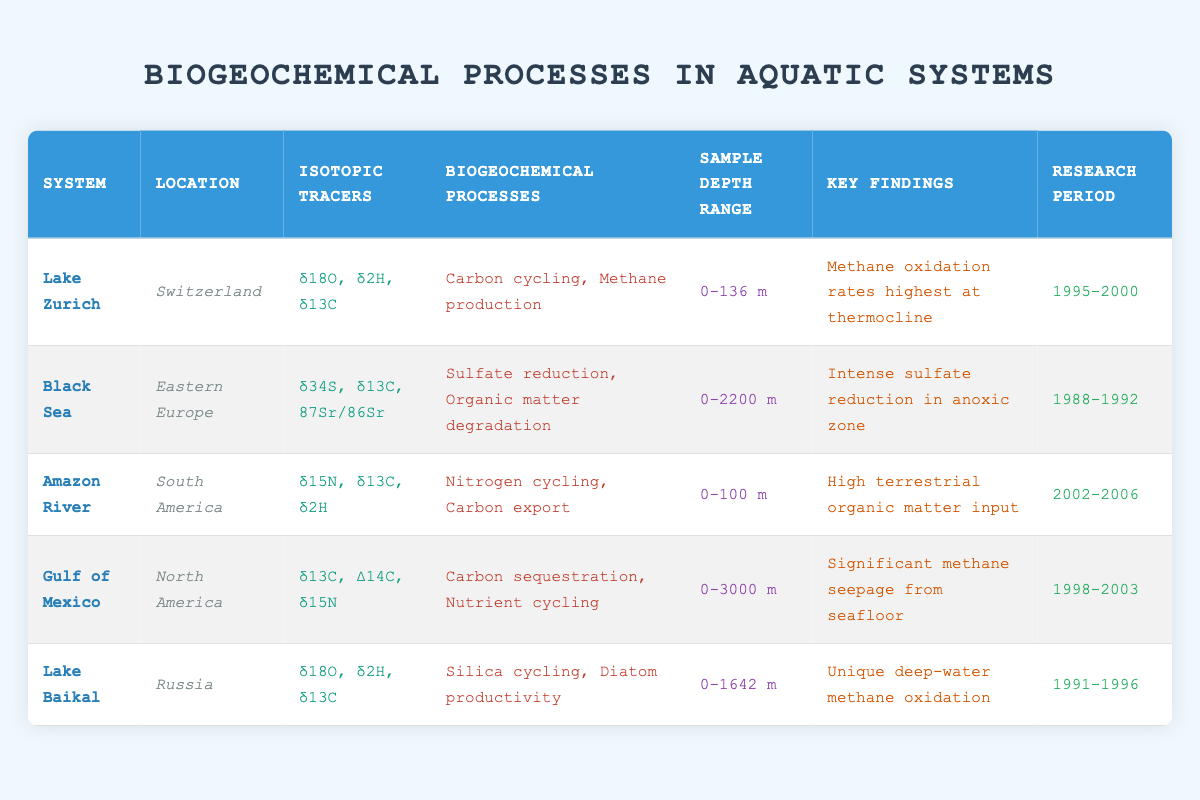What isotopic tracers are used in the Black Sea? The table lists the isotopic tracers utilized in the Black Sea as δ34S, δ13C, and 87Sr/86Sr, which can be found in the relevant row under the "Isotopic Tracers" column.
Answer: δ34S, δ13C, 87Sr/86Sr Which aquatic system has the deepest sample depth range? From the depth range column, the Gulf of Mexico has a sample depth range of 0-3000 m, which is the largest compared to the other systems listed.
Answer: Gulf of Mexico Is carbon cycling one of the primary biogeochemical processes studied in Lake Baikal? By inspecting the "Primary Biogeochemical Processes" column for Lake Baikal, it can be seen that the processes include silica cycling and diatom productivity, meaning carbon cycling is not studied there.
Answer: No What is the research period for the Amazon River study? The research period for the Amazon River study can be found in the "Research Period" column, which states the period as 2002-2006.
Answer: 2002-2006 Which system had key findings related to intense sulfate reduction? The key finding regarding intense sulfate reduction is associated with the Black Sea, as seen in the corresponding row's "Key Findings" column, indicating this specific biogeochemical activity.
Answer: Black Sea How many different isotopic tracers are used across all systems in the table? By enumerating the distinct isotopic tracers from each system, δ18O, δ2H, δ13C, δ34S, 87Sr/86Sr, δ15N, and Δ14C, a total of 7 unique tracers can be identified across the aquatic systems listed in the table.
Answer: 7 Does the Gulf of Mexico have significant methane seepage according to the key findings? Observing the "Key Findings" for the Gulf of Mexico, it explicitly mentions significant methane seepage from the seafloor, confirming the true nature of this fact.
Answer: Yes What is the difference in the maximum sample depth ranges between the Gulf of Mexico and Lake Zurich? The maximum sample depth for the Gulf of Mexico is 3000 m and for Lake Zurich is 136 m. Thus, the difference is computed as 3000 - 136 = 2864 m, which illustrates the contrast in depths.
Answer: 2864 m Which aquatic system reported high terrestrial organic matter input during its study? The findings for the system studying high terrestrial organic matter input directly refer to the Amazon River under the "Key Findings" column, showcasing the importance of terrestrial contributions to the aquatic system.
Answer: Amazon River 